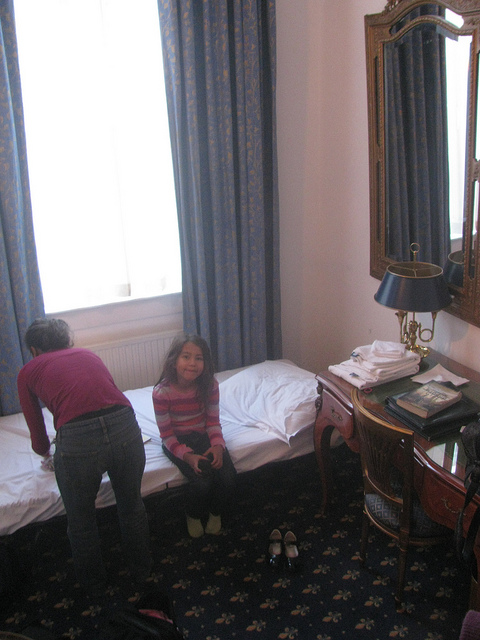Can you describe the style of the room? The room features a classic decor with floral-patterned carpet, traditional furniture, heavy drapery, and a decorative mirror suggesting an elegant, perhaps vintage style. Does the room seem to be in a personal home or another type of space? Given the presence of multiple identical beds with neatly folded linens on top, and the luggage resting by the wall, it's likely this room is part of a hotel or similar accommodation. 